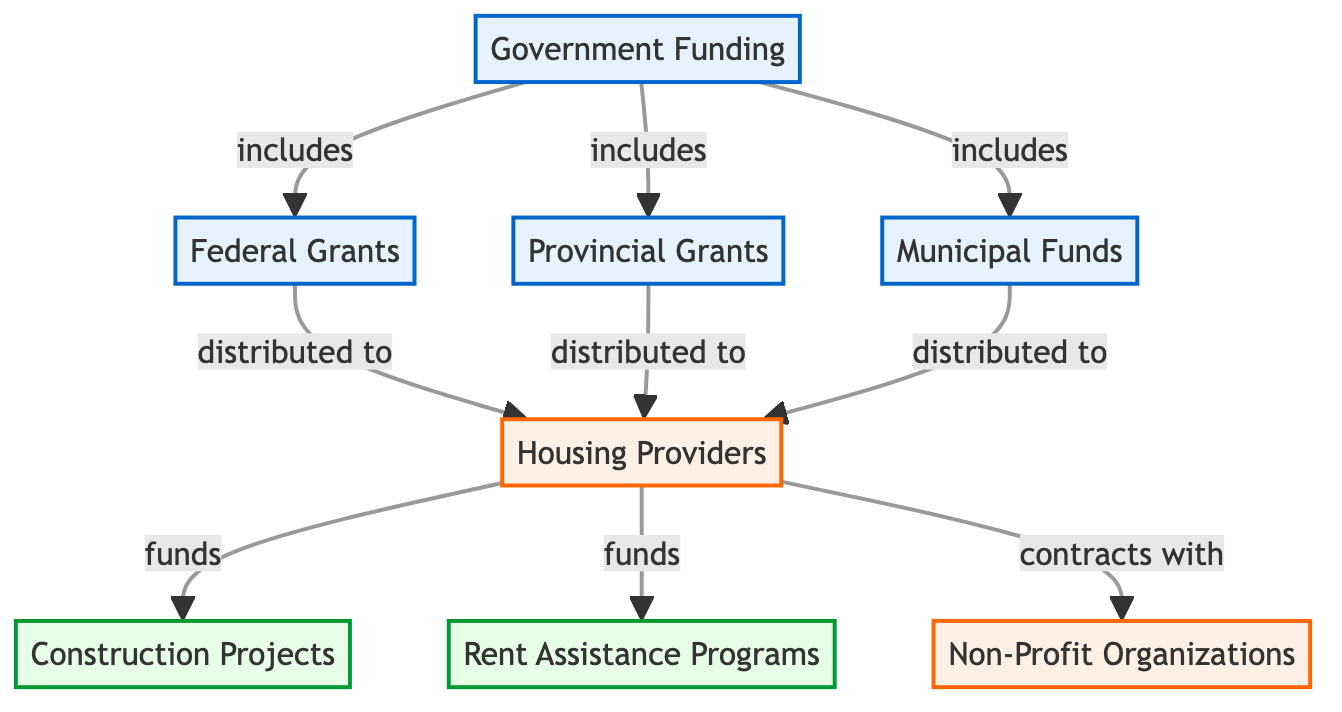What types of funding are included under Government Funding? The diagram shows three specific types of funding: Federal Grants, Provincial Grants, and Municipal Funds, all of which are linked directly to the Government Funding node.
Answer: Federal Grants, Provincial Grants, Municipal Funds How many types of programs are funded by Housing Providers? The diagram illustrates that Housing Providers fund two distinct programs: Construction Projects and Rent Assistance Programs, indicating there are two types of programs.
Answer: 2 Which organization contracts with Housing Providers? The diagram indicates that Housing Providers have contracts with Non-Profit Organizations, establishing a direct connection between the two nodes.
Answer: Non-Profit Organizations What is the relationship between Federal Grants and Housing Providers? The diagram shows that Federal Grants are distributed to Housing Providers, indicating a flow of funding from Federal Grants to the Providers.
Answer: distributed to How many different funding sources are reflected in the diagram? The diagram displays three distinct funding sources: Federal Grants, Provincial Grants, and Municipal Funds. Counting these, there are a total of three sources represented.
Answer: 3 What is the primary source of funds for construction projects? According to the diagram, the primary source of funds for Construction Projects is Housing Providers, who allocate funding to these programs directly.
Answer: Housing Providers Which type of funding do Municipal Funds represent in the diagram? The diagram categorizes Municipal Funds as one of the sources under Government Funding, linking it to the wider funding scheme for housing programs.
Answer: Government Funding What kind of funds are utilized for Rent Assistance Programs? The diagram specifies that Rent Assistance Programs are funded directly by Housing Providers, indicating that these funds come from there.
Answer: Housing Providers 